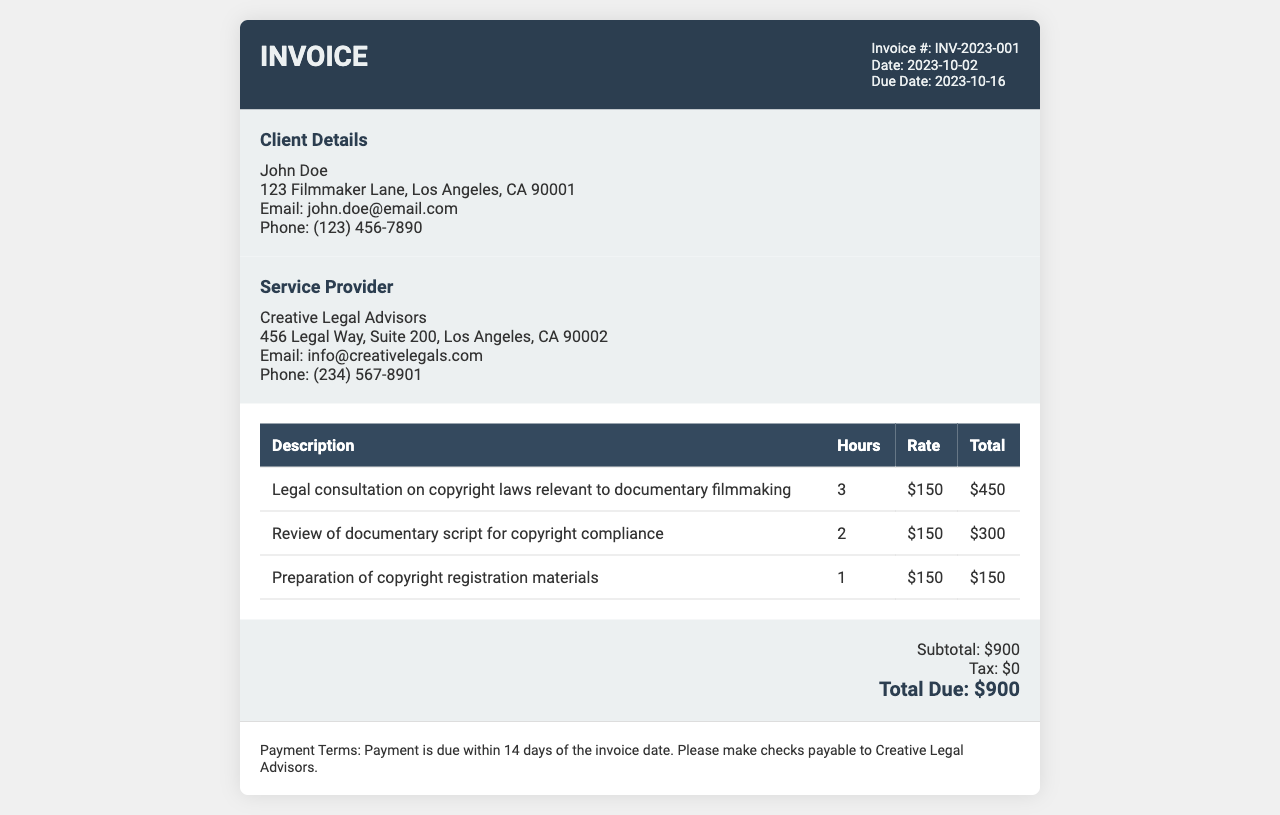What is the invoice number? The invoice number is clearly stated in the document header.
Answer: INV-2023-001 Who is the client? The client's name and contact information can be found in the client details section.
Answer: John Doe What is the total amount due? The total amount due is summarized at the bottom of the invoice.
Answer: $900 How many hours were spent on reviewing the documentary script? This information can be found in the services section under the corresponding task.
Answer: 2 What is the due date for payment? The due date is indicated in the invoice details section.
Answer: 2023-10-16 What is the rate per hour for the legal consultation? The hourly rate is listed next to each service description in the services table.
Answer: $150 What payment terms are mentioned? Payment terms are described at the bottom of the invoice, detailing when payment should be made.
Answer: Payment is due within 14 days of the invoice date How many services are listed in the invoice? By counting the entries in the services table, the number of services can be determined.
Answer: 3 What is the total hours of consultation provided? The total hours can be derived from summing the hours listed in the services table.
Answer: 6 